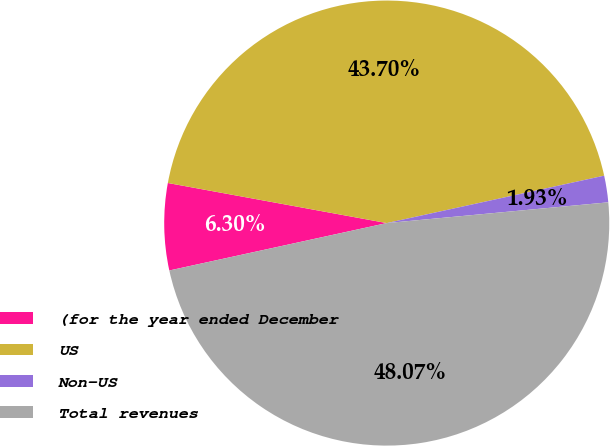Convert chart. <chart><loc_0><loc_0><loc_500><loc_500><pie_chart><fcel>(for the year ended December<fcel>US<fcel>Non-US<fcel>Total revenues<nl><fcel>6.3%<fcel>43.7%<fcel>1.93%<fcel>48.07%<nl></chart> 